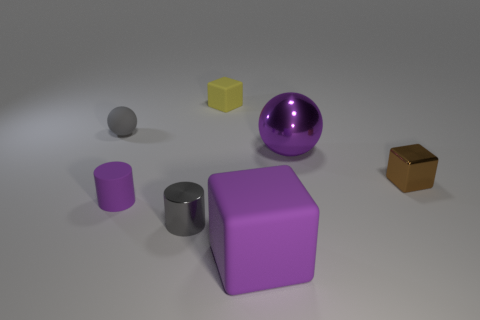Add 1 small purple cylinders. How many objects exist? 8 Subtract all balls. How many objects are left? 5 Subtract all brown shiny blocks. Subtract all tiny gray matte spheres. How many objects are left? 5 Add 5 tiny purple things. How many tiny purple things are left? 6 Add 3 red matte things. How many red matte things exist? 3 Subtract 1 yellow cubes. How many objects are left? 6 